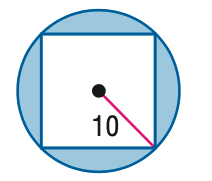Answer the mathemtical geometry problem and directly provide the correct option letter.
Question: Find the area of the shaded region. Assume that all polygons that appear to be regular are regular. Round to the nearest tenth.
Choices: A: 114.2 B: 214.2 C: 264.2 D: 314.2 A 